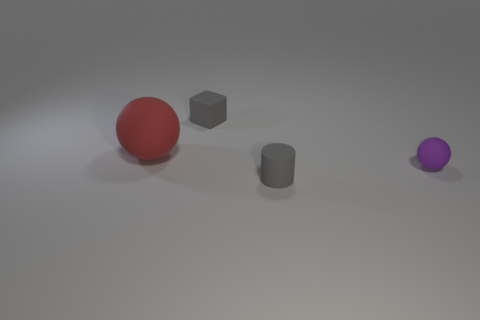Add 4 small red metal cylinders. How many objects exist? 8 Subtract all cubes. How many objects are left? 3 Add 2 gray rubber objects. How many gray rubber objects exist? 4 Subtract 1 red spheres. How many objects are left? 3 Subtract all cyan spheres. Subtract all matte cylinders. How many objects are left? 3 Add 4 tiny objects. How many tiny objects are left? 7 